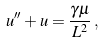Convert formula to latex. <formula><loc_0><loc_0><loc_500><loc_500>u ^ { \prime \prime } + u = \frac { \gamma \mu } { L ^ { 2 } } \, ,</formula> 